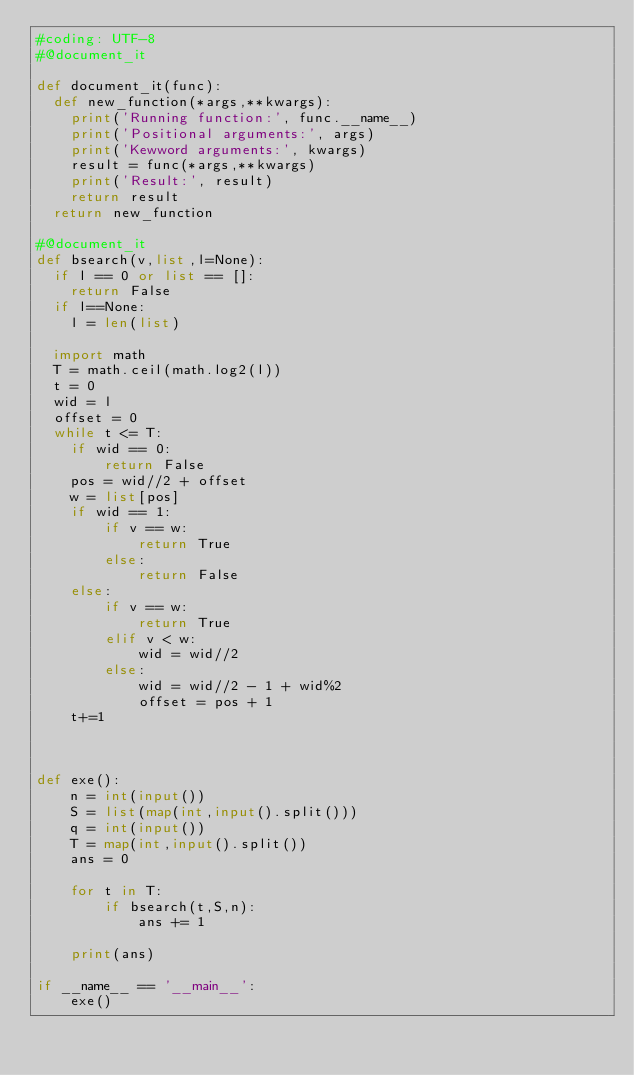Convert code to text. <code><loc_0><loc_0><loc_500><loc_500><_Python_>#coding: UTF-8
#@document_it

def document_it(func):
  def new_function(*args,**kwargs):
    print('Running function:', func.__name__)
    print('Positional arguments:', args)
    print('Kewword arguments:', kwargs)
    result = func(*args,**kwargs)
    print('Result:', result)
    return result
  return new_function

#@document_it
def bsearch(v,list,l=None):
  if l == 0 or list == []:
    return False
  if l==None:
    l = len(list)
  
  import math
  T = math.ceil(math.log2(l))
  t = 0
  wid = l
  offset = 0
  while t <= T:
    if wid == 0:
        return False
    pos = wid//2 + offset
    w = list[pos]
    if wid == 1:
        if v == w:
            return True
        else:
            return False
    else:
        if v == w:
            return True
        elif v < w:
            wid = wid//2
        else:
            wid = wid//2 - 1 + wid%2
            offset = pos + 1
    t+=1



def exe():
    n = int(input())
    S = list(map(int,input().split()))
    q = int(input())
    T = map(int,input().split())
    ans = 0

    for t in T:
        if bsearch(t,S,n):
            ans += 1

    print(ans)

if __name__ == '__main__':
    exe()
</code> 